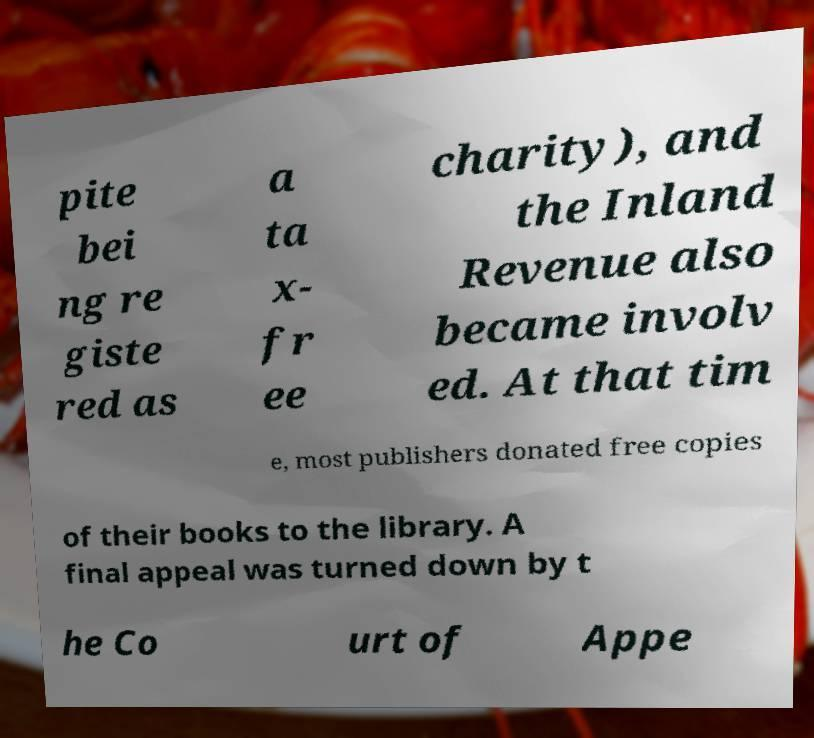Please read and relay the text visible in this image. What does it say? pite bei ng re giste red as a ta x- fr ee charity), and the Inland Revenue also became involv ed. At that tim e, most publishers donated free copies of their books to the library. A final appeal was turned down by t he Co urt of Appe 